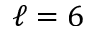Convert formula to latex. <formula><loc_0><loc_0><loc_500><loc_500>\ell = 6</formula> 